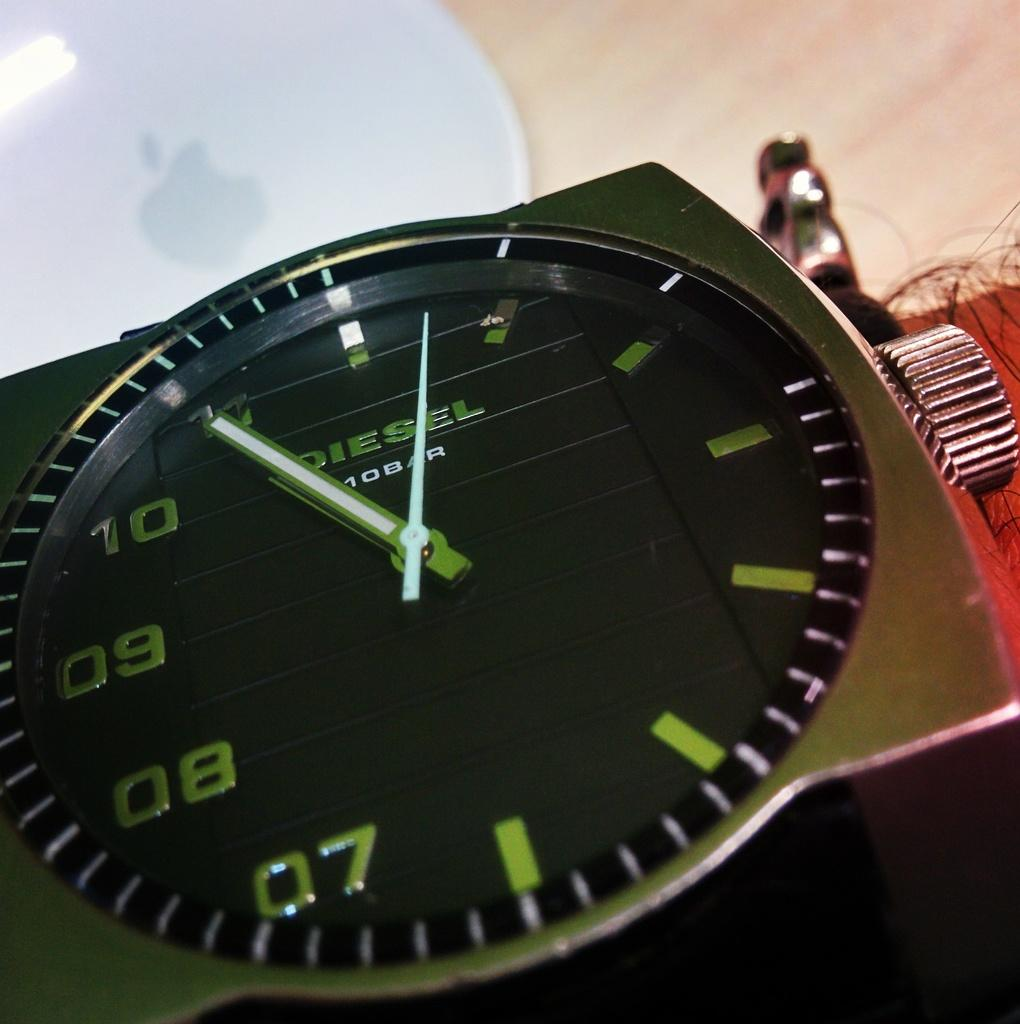<image>
Relay a brief, clear account of the picture shown. A Diesel brand watch on a hairy man's wrist. 